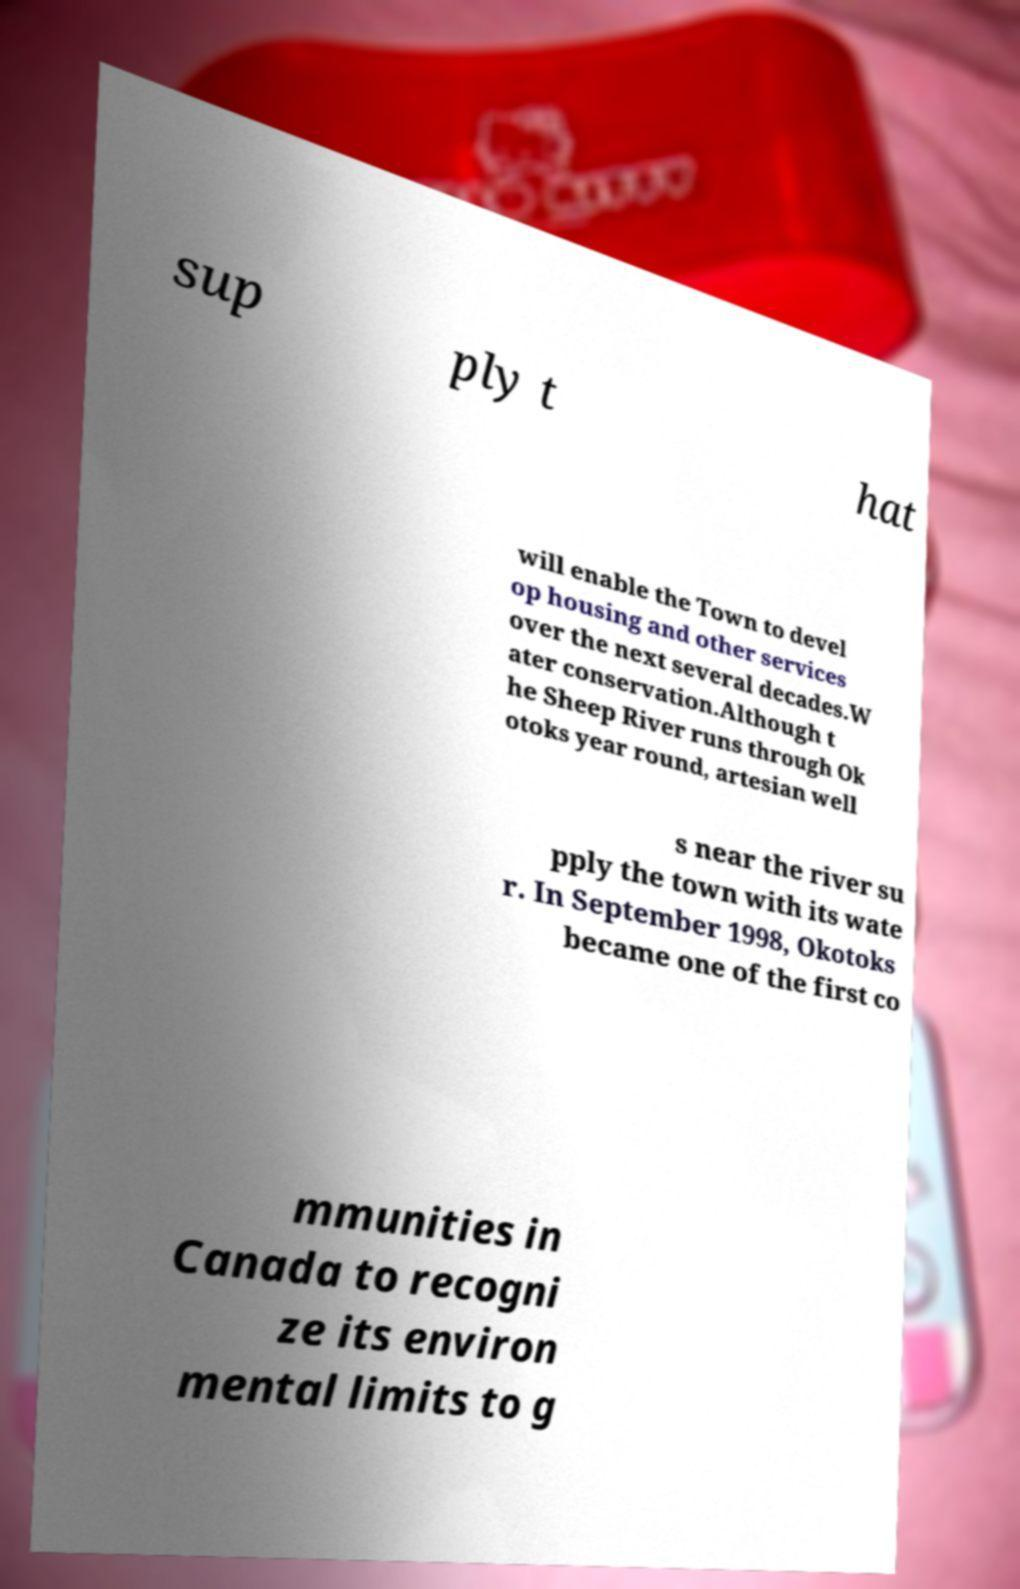Could you assist in decoding the text presented in this image and type it out clearly? sup ply t hat will enable the Town to devel op housing and other services over the next several decades.W ater conservation.Although t he Sheep River runs through Ok otoks year round, artesian well s near the river su pply the town with its wate r. In September 1998, Okotoks became one of the first co mmunities in Canada to recogni ze its environ mental limits to g 